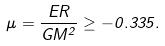Convert formula to latex. <formula><loc_0><loc_0><loc_500><loc_500>\mu = \frac { E R } { G M ^ { 2 } } \geq - 0 . 3 3 5 .</formula> 